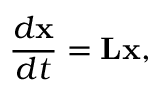Convert formula to latex. <formula><loc_0><loc_0><loc_500><loc_500>\frac { d x } { d t } = L x ,</formula> 